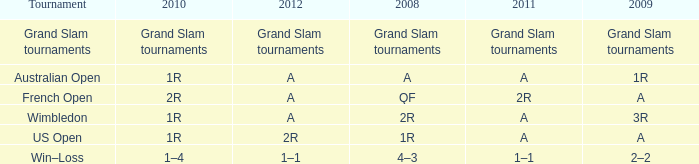Name the 2010 for 2011 of a and 2008 of 1r 1R. 